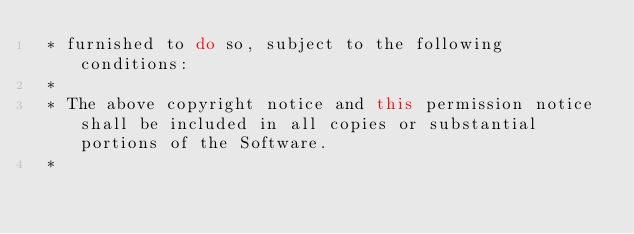<code> <loc_0><loc_0><loc_500><loc_500><_Java_> * furnished to do so, subject to the following conditions:
 *
 * The above copyright notice and this permission notice shall be included in all copies or substantial portions of the Software.
 *</code> 